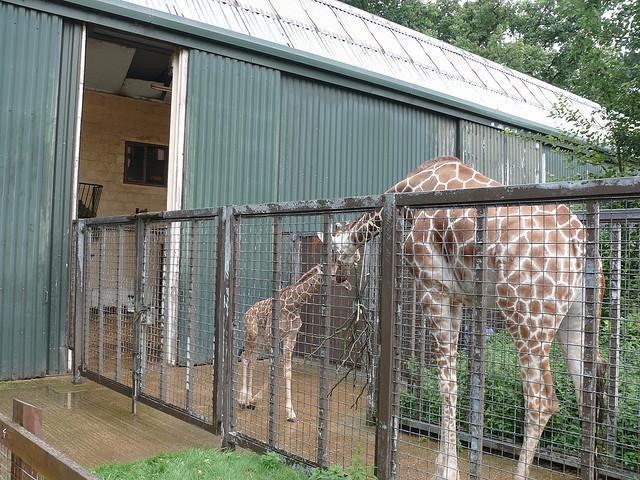How many giraffes are in the picture?
Give a very brief answer. 2. 